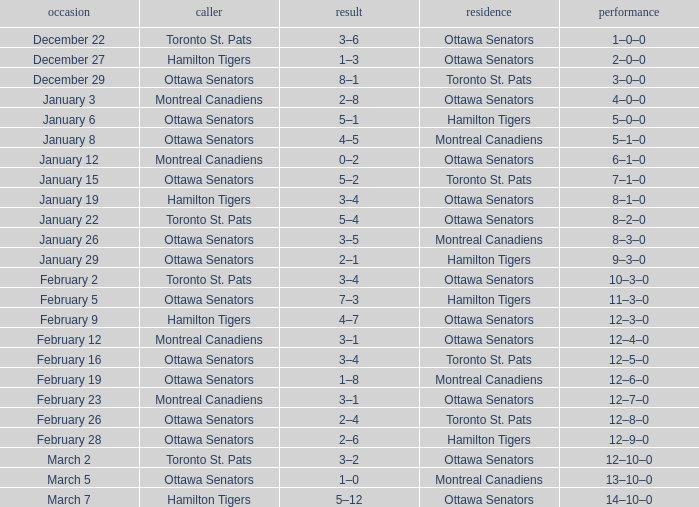What is the record for the game on January 19? 8–1–0. 